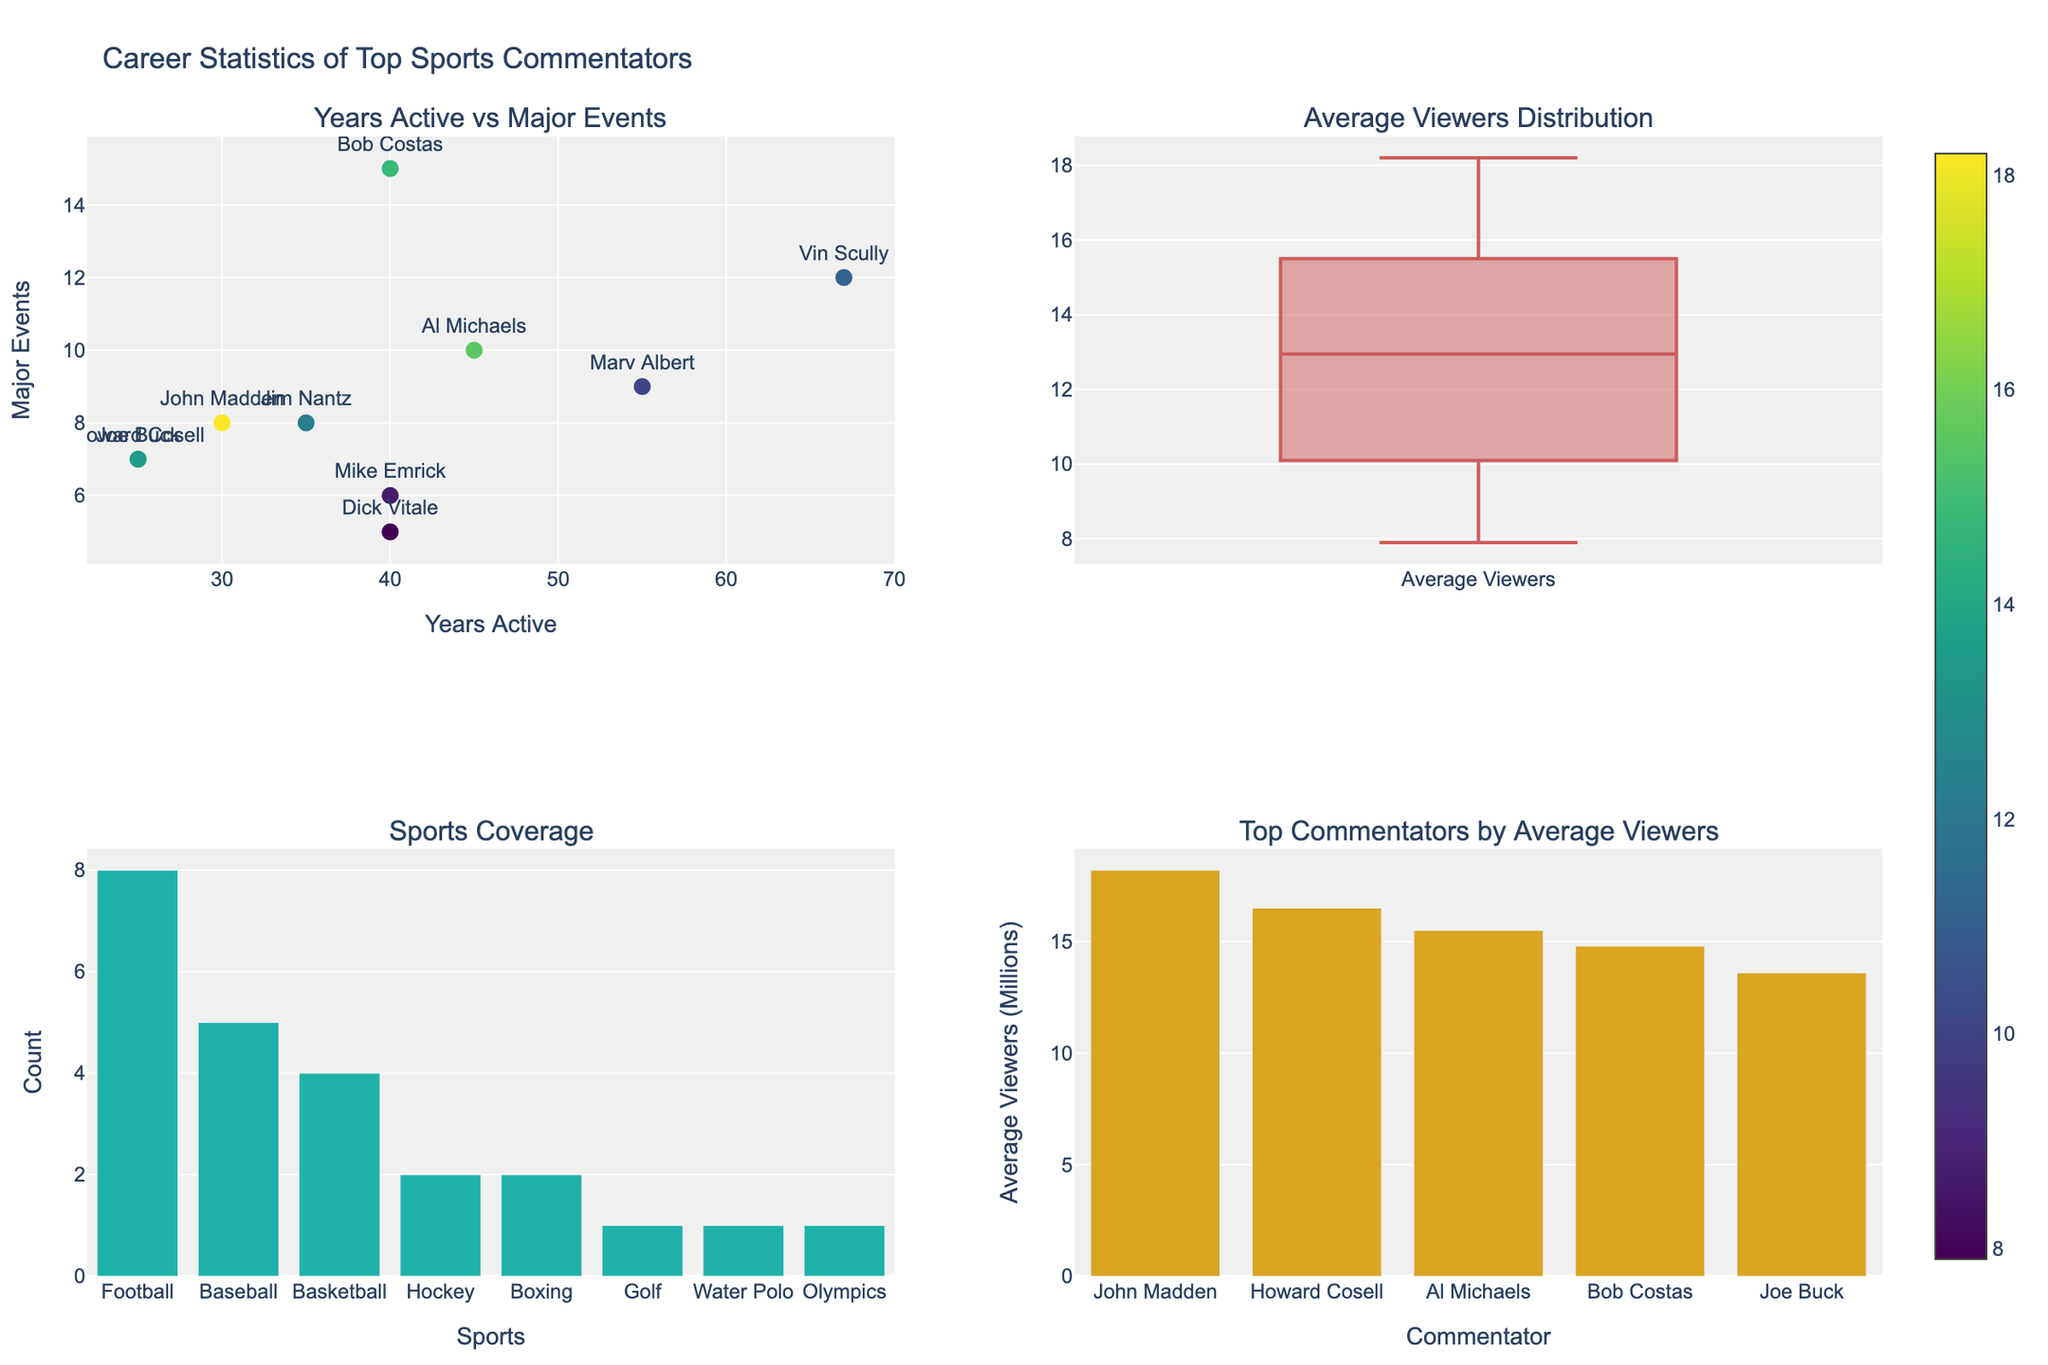What are the subplot titles? There are four subplot titles: "Years Active vs Major Events", "Average Viewers Distribution", "Sports Coverage", and "Top Commentators by Average Viewers".
Answer: Years Active vs Major Events; Average Viewers Distribution; Sports Coverage; Top Commentators by Average Viewers Which commentator has the highest average viewers? In the "Top Commentators by Average Viewers" subplot (bottom-right), the tallest bar represents John Madden, indicating he has the highest average viewers.
Answer: John Madden How many sports did Bob Costas cover? In the "Sports Coverage" subplot (bottom-left), we can see the breakdown of sports covered. Consulting the dataset, Bob Costas covered three sports: Baseball, Football, and Olympics.
Answer: 3 What is the range of years active among the commentators? In the "Years Active vs Major Events" subplot (top-left), the x-axis shows the range of years active, from the minimum being Howard Cosell's 25 years to the maximum being Vin Scully's 67 years, covering a range of 67 - 25 = 42 years.
Answer: 42 years What is the median average viewers across all commentators? In the "Average Viewers Distribution" subplot (top-right), there is a box plot representing the distribution of average viewers. The median value (the line in the center of the box) is around 13.6 million viewers.
Answer: 13.6 million viewers Which sport is covered the most by the commentators? In the "Sports Coverage" subplot (bottom-left), the bar for 'Football' is the tallest, indicating it is the most covered sport.
Answer: Football How many commentators have covered more than 10 major events? By inspecting the "Years Active vs Major Events" subplot (top-left), we see that Al Michaels and Vin Scully are the only commentators who have covered more than 10 major events.
Answer: 2 Which commentator had the longest career span? In the "Years Active vs Major Events" subplot (top-left), the rightmost data point represents Vin Scully with 67 years active.
Answer: Vin Scully Are there more commentators who have average viewers above or below 15 million? Analyzing the "Average Viewers Distribution" subplot (top-right) would show if the majority of data points lie above or below. By quickly counting, more data points are below 15 million than above.
Answer: Below 15 million 